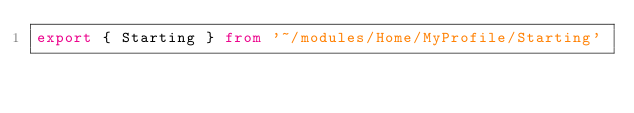<code> <loc_0><loc_0><loc_500><loc_500><_TypeScript_>export { Starting } from '~/modules/Home/MyProfile/Starting'
</code> 